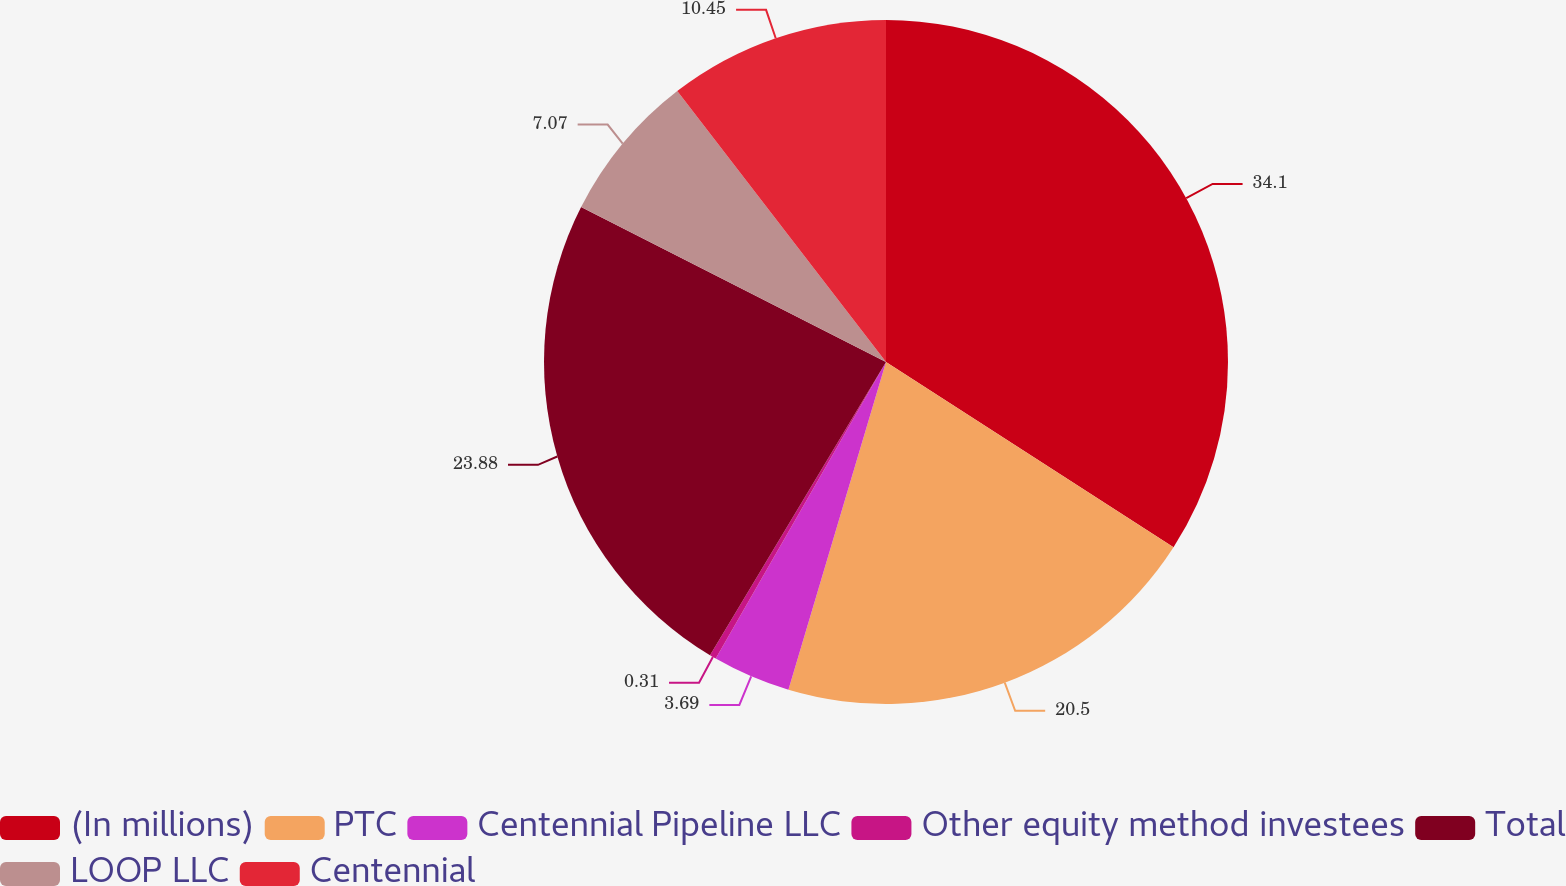Convert chart to OTSL. <chart><loc_0><loc_0><loc_500><loc_500><pie_chart><fcel>(In millions)<fcel>PTC<fcel>Centennial Pipeline LLC<fcel>Other equity method investees<fcel>Total<fcel>LOOP LLC<fcel>Centennial<nl><fcel>34.11%<fcel>20.5%<fcel>3.69%<fcel>0.31%<fcel>23.88%<fcel>7.07%<fcel>10.45%<nl></chart> 